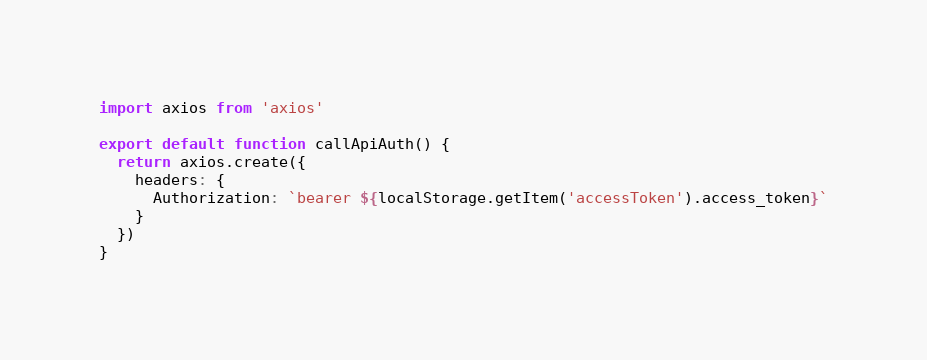<code> <loc_0><loc_0><loc_500><loc_500><_JavaScript_>import axios from 'axios'

export default function callApiAuth() {
  return axios.create({
    headers: {
      Authorization: `bearer ${localStorage.getItem('accessToken').access_token}`
    }
  })
}
</code> 